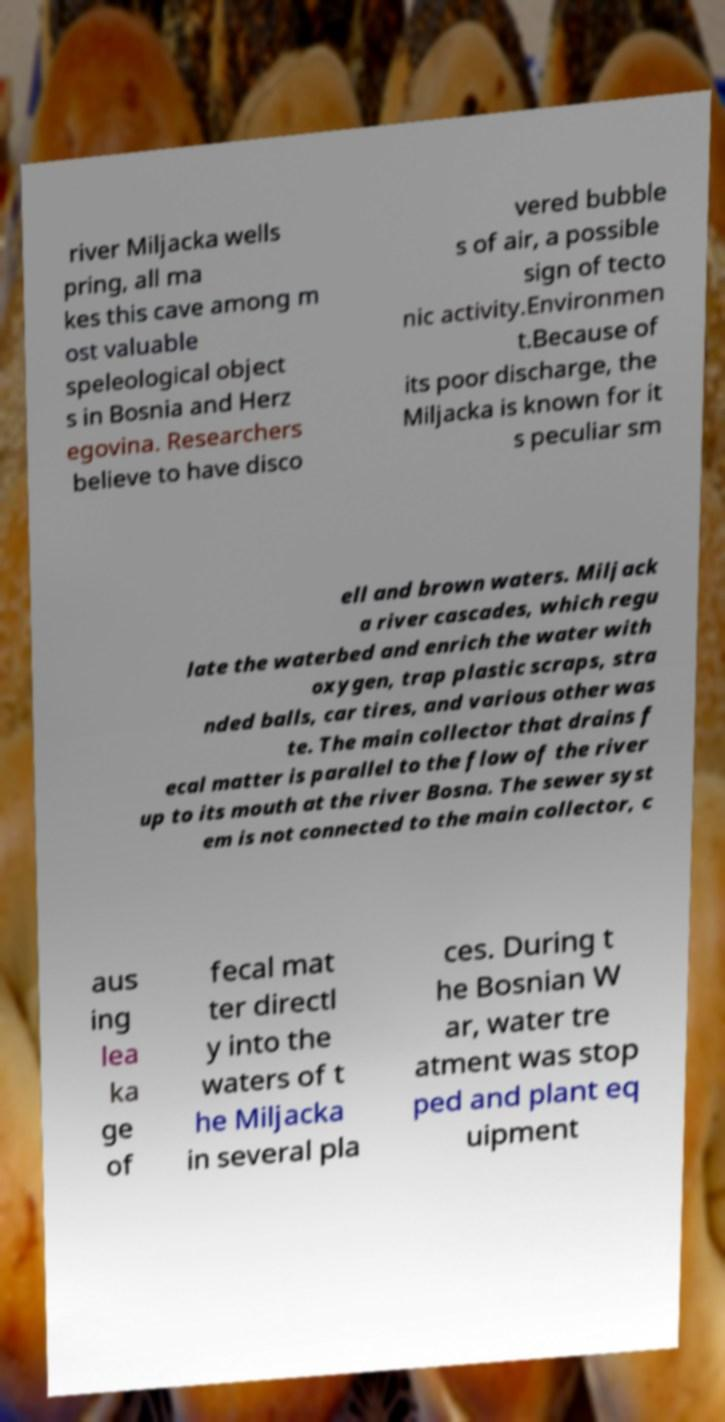Can you read and provide the text displayed in the image?This photo seems to have some interesting text. Can you extract and type it out for me? river Miljacka wells pring, all ma kes this cave among m ost valuable speleological object s in Bosnia and Herz egovina. Researchers believe to have disco vered bubble s of air, a possible sign of tecto nic activity.Environmen t.Because of its poor discharge, the Miljacka is known for it s peculiar sm ell and brown waters. Miljack a river cascades, which regu late the waterbed and enrich the water with oxygen, trap plastic scraps, stra nded balls, car tires, and various other was te. The main collector that drains f ecal matter is parallel to the flow of the river up to its mouth at the river Bosna. The sewer syst em is not connected to the main collector, c aus ing lea ka ge of fecal mat ter directl y into the waters of t he Miljacka in several pla ces. During t he Bosnian W ar, water tre atment was stop ped and plant eq uipment 